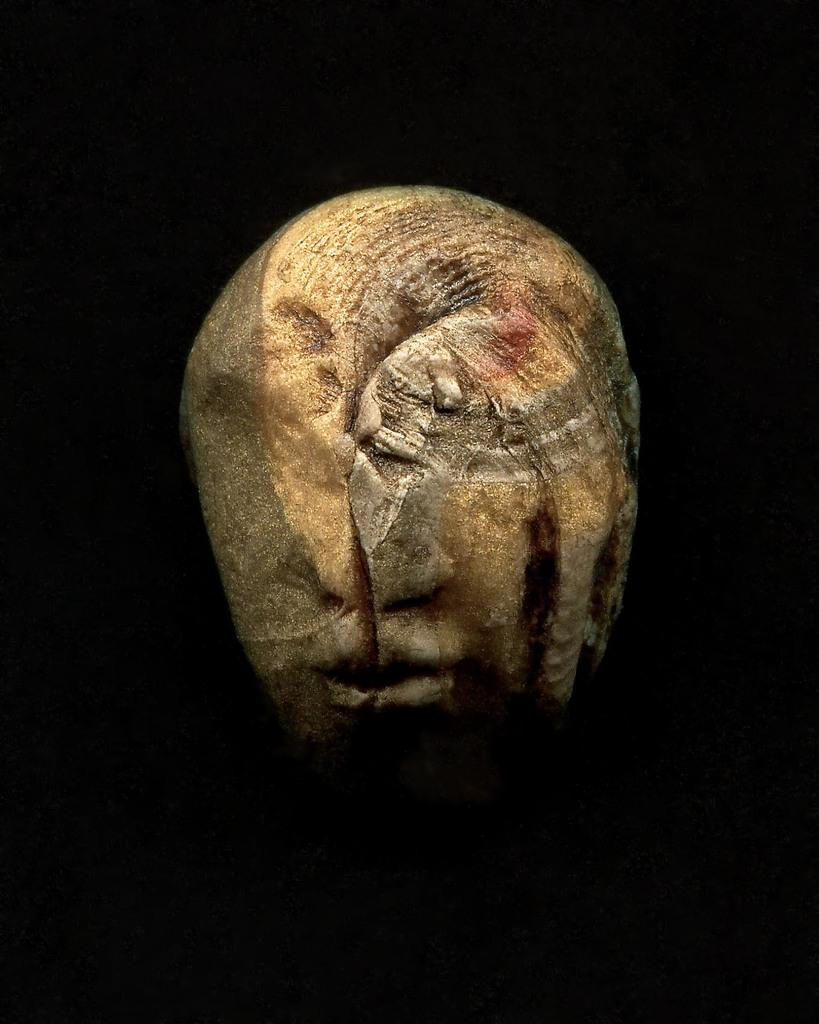What is the main subject of the image? There is a sculpture in the image. What color is the background of the image? The background of the image is black in color. What type of yoke is being used to fuel the sculpture in the image? There is no yoke or fuel present in the image; it features a sculpture with a black background. 